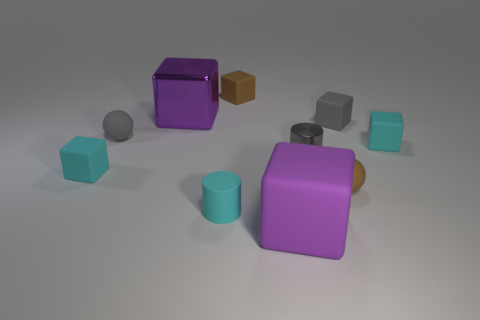Subtract all tiny matte blocks. How many blocks are left? 2 Subtract all brown balls. How many balls are left? 1 Subtract 0 purple spheres. How many objects are left? 10 Subtract all cylinders. How many objects are left? 8 Subtract 2 cylinders. How many cylinders are left? 0 Subtract all red cubes. Subtract all blue balls. How many cubes are left? 6 Subtract all green balls. How many gray cubes are left? 1 Subtract all large cyan spheres. Subtract all gray spheres. How many objects are left? 9 Add 1 big purple objects. How many big purple objects are left? 3 Add 9 purple matte blocks. How many purple matte blocks exist? 10 